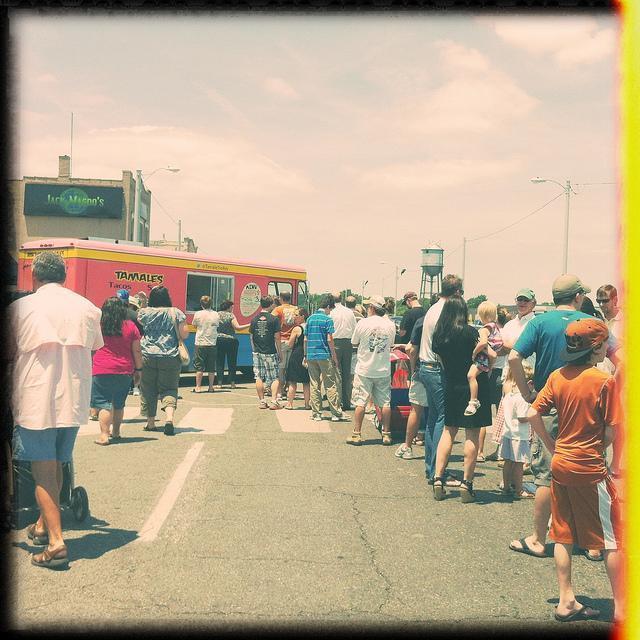How many people are there?
Give a very brief answer. 11. How many of the airplanes have entrails?
Give a very brief answer. 0. 